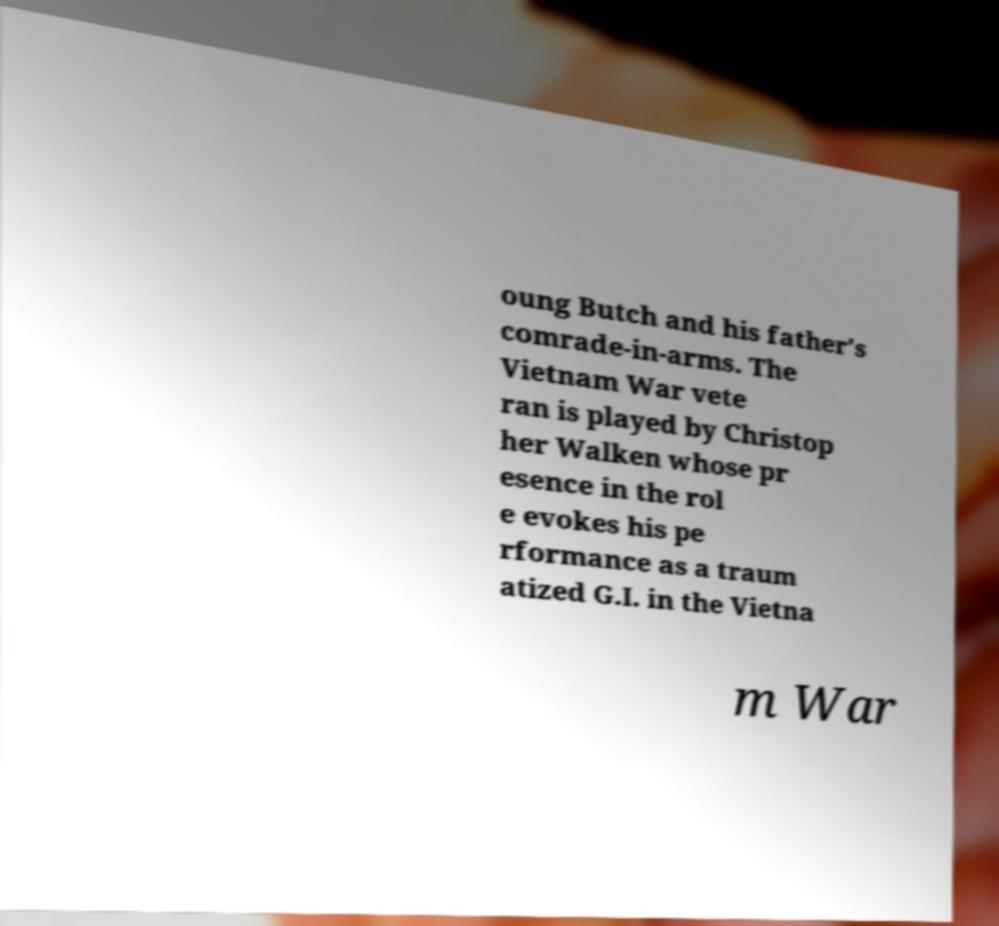Can you read and provide the text displayed in the image?This photo seems to have some interesting text. Can you extract and type it out for me? oung Butch and his father's comrade-in-arms. The Vietnam War vete ran is played by Christop her Walken whose pr esence in the rol e evokes his pe rformance as a traum atized G.I. in the Vietna m War 